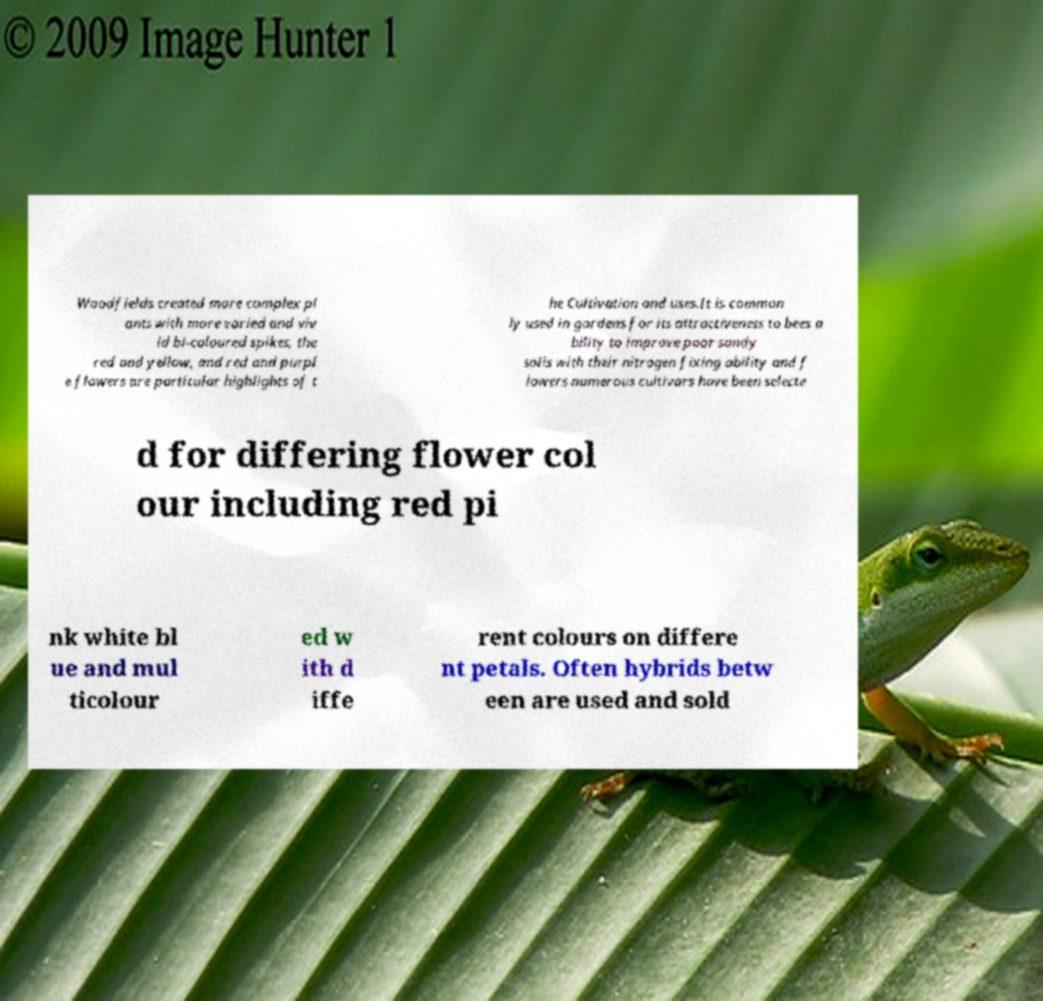What messages or text are displayed in this image? I need them in a readable, typed format. Woodfields created more complex pl ants with more varied and viv id bi-coloured spikes, the red and yellow, and red and purpl e flowers are particular highlights of t he Cultivation and uses.It is common ly used in gardens for its attractiveness to bees a bility to improve poor sandy soils with their nitrogen fixing ability and f lowers numerous cultivars have been selecte d for differing flower col our including red pi nk white bl ue and mul ticolour ed w ith d iffe rent colours on differe nt petals. Often hybrids betw een are used and sold 